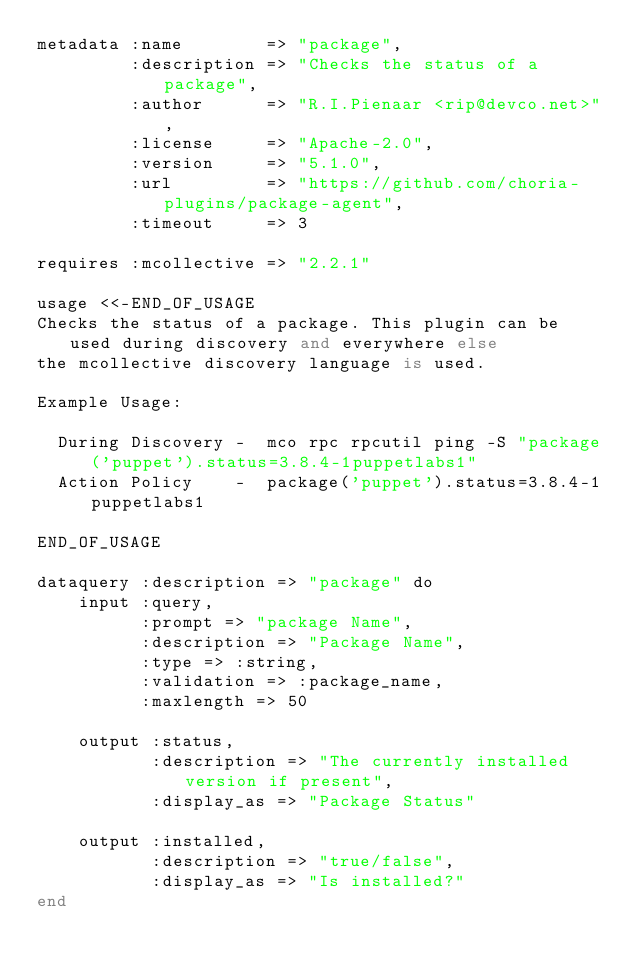<code> <loc_0><loc_0><loc_500><loc_500><_SQL_>metadata :name        => "package",
         :description => "Checks the status of a package",
         :author      => "R.I.Pienaar <rip@devco.net>",
         :license     => "Apache-2.0",
         :version     => "5.1.0",
         :url         => "https://github.com/choria-plugins/package-agent",
         :timeout     => 3

requires :mcollective => "2.2.1"

usage <<-END_OF_USAGE
Checks the status of a package. This plugin can be used during discovery and everywhere else
the mcollective discovery language is used.

Example Usage:

  During Discovery -  mco rpc rpcutil ping -S "package('puppet').status=3.8.4-1puppetlabs1"
  Action Policy    -  package('puppet').status=3.8.4-1puppetlabs1

END_OF_USAGE

dataquery :description => "package" do
    input :query,
          :prompt => "package Name",
          :description => "Package Name",
          :type => :string,
          :validation => :package_name,
          :maxlength => 50

    output :status,
           :description => "The currently installed version if present",
           :display_as => "Package Status"

    output :installed,
           :description => "true/false",
           :display_as => "Is installed?"
end

</code> 